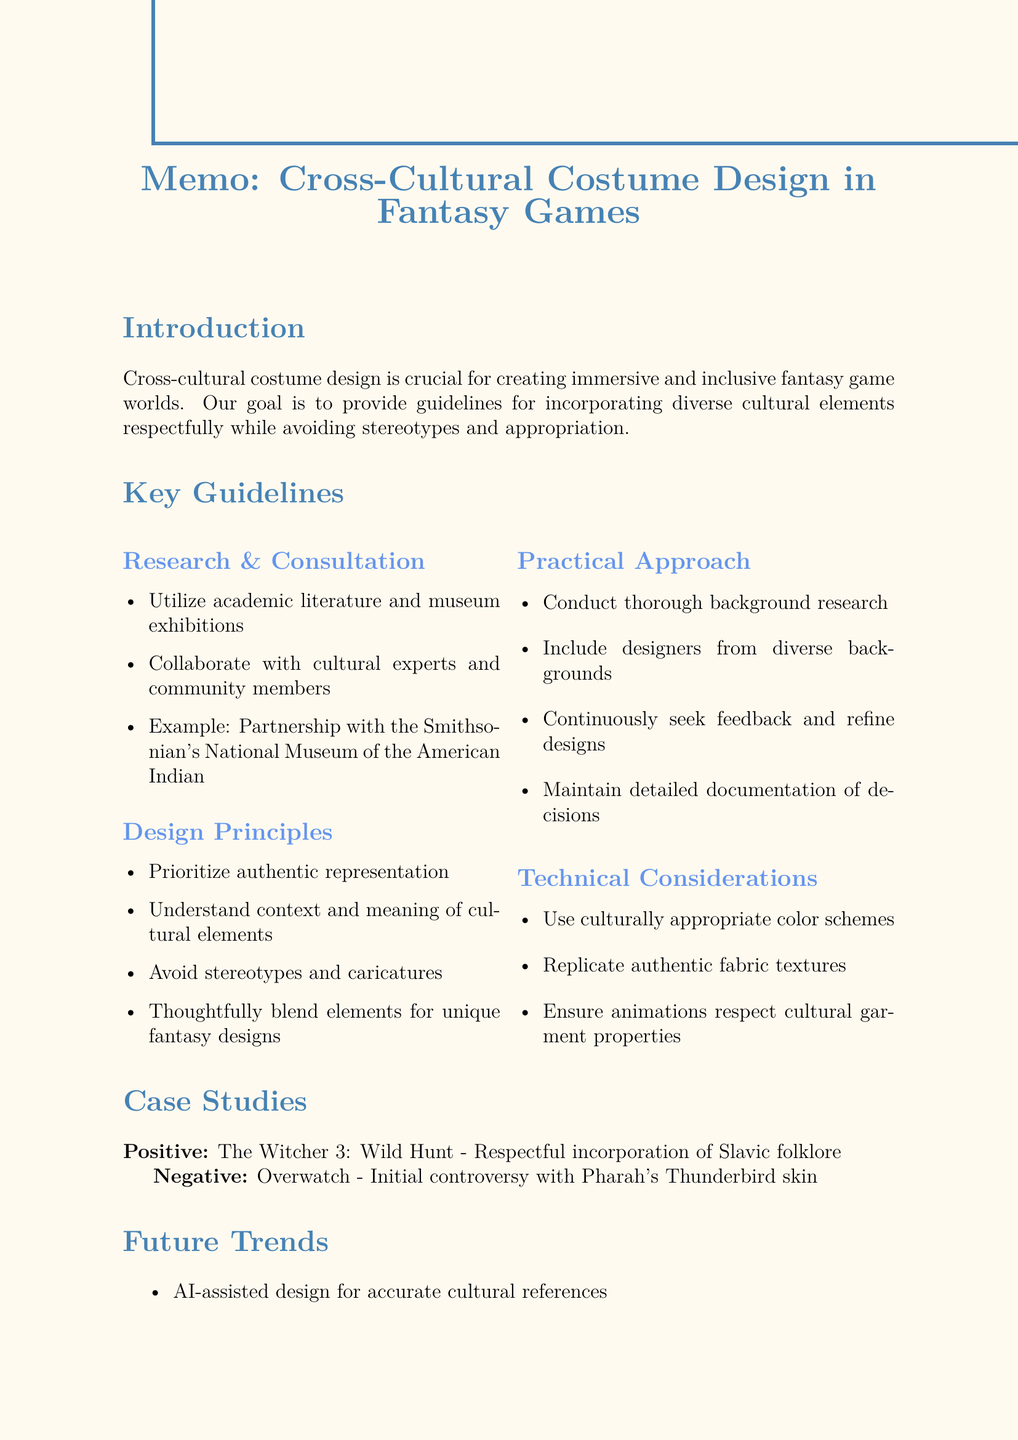What is the primary goal of cross-cultural costume design? The primary goal is to provide guidelines for incorporating diverse cultural elements respectfully and thoughtfully.
Answer: Provide guidelines for incorporating diverse cultural elements respectfully and thoughtfully What popular game is cited as a positive example of cross-cultural costume design? The positive example mentioned is a specific game that effectively incorporates cultural elements.
Answer: The Witcher 3: Wild Hunt Who should be included in the design process for diverse perspectives? The document advises including a specific demographic in the creative process for better representation.
Answer: Designers from diverse backgrounds What should be prioritized according to the design principles? The document emphasizes a particular aspect that should be given the highest consideration in the design of costumes.
Answer: Accurate representation of cultural elements What is mentioned as a negative example of cultural representation in gaming? This question requires recalling a specific instance that faced backlash regarding representation.
Answer: Overwatch What is suggested to educate players about cultural inspirations? There is a recommended method for sharing information with players about the cultural backgrounds that inspire the game.
Answer: Use game lore and supplementary materials Which organization is mentioned as a collaborator for accurate representation? The document provides the name of an institution that has partnered with game developers for cultural consultation.
Answer: Smithsonian's National Museum of the American Indian Which aspect of costume design involves maintaining detailed records? A particular aspect of the practical guidelines emphasizes the importance of record-keeping for transparency.
Answer: Documentation What technology is suggested for future trends in costume design? The document mentions a type of technology that could enhance design accuracy and gameplay experience in the future.
Answer: AI-assisted design 